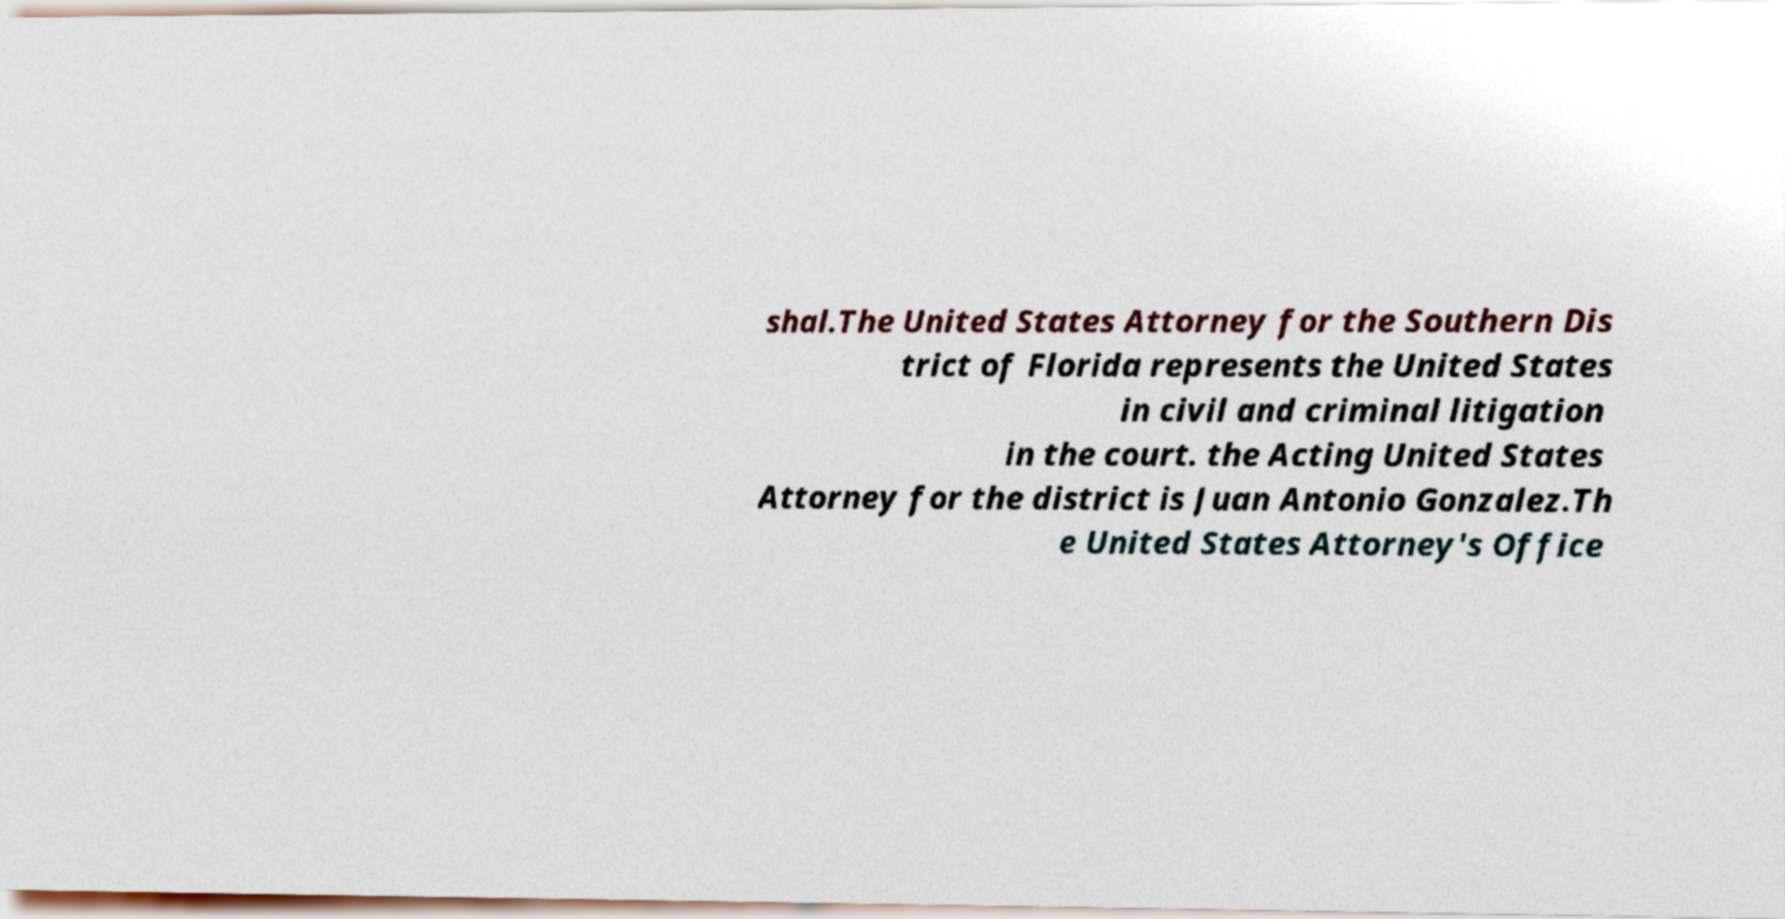Could you assist in decoding the text presented in this image and type it out clearly? shal.The United States Attorney for the Southern Dis trict of Florida represents the United States in civil and criminal litigation in the court. the Acting United States Attorney for the district is Juan Antonio Gonzalez.Th e United States Attorney's Office 